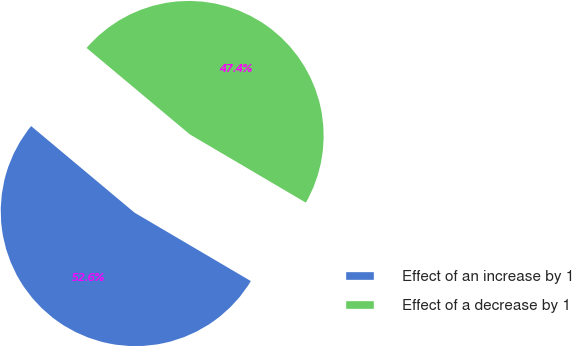Convert chart. <chart><loc_0><loc_0><loc_500><loc_500><pie_chart><fcel>Effect of an increase by 1<fcel>Effect of a decrease by 1<nl><fcel>52.63%<fcel>47.37%<nl></chart> 